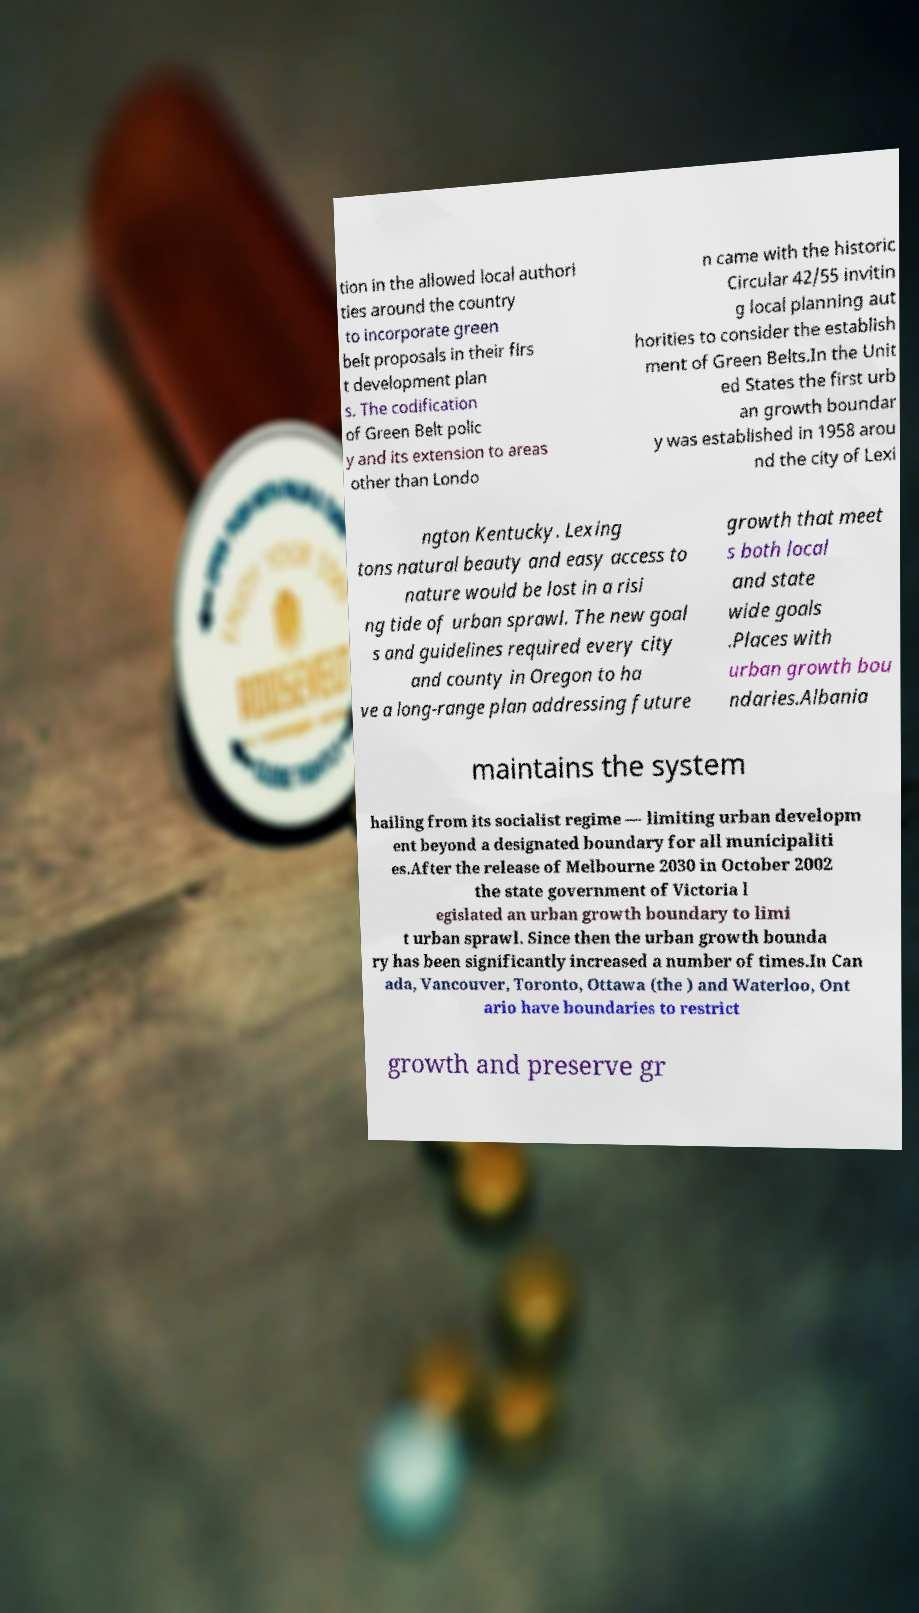For documentation purposes, I need the text within this image transcribed. Could you provide that? tion in the allowed local authori ties around the country to incorporate green belt proposals in their firs t development plan s. The codification of Green Belt polic y and its extension to areas other than Londo n came with the historic Circular 42/55 invitin g local planning aut horities to consider the establish ment of Green Belts.In the Unit ed States the first urb an growth boundar y was established in 1958 arou nd the city of Lexi ngton Kentucky. Lexing tons natural beauty and easy access to nature would be lost in a risi ng tide of urban sprawl. The new goal s and guidelines required every city and county in Oregon to ha ve a long-range plan addressing future growth that meet s both local and state wide goals .Places with urban growth bou ndaries.Albania maintains the system hailing from its socialist regime — limiting urban developm ent beyond a designated boundary for all municipaliti es.After the release of Melbourne 2030 in October 2002 the state government of Victoria l egislated an urban growth boundary to limi t urban sprawl. Since then the urban growth bounda ry has been significantly increased a number of times.In Can ada, Vancouver, Toronto, Ottawa (the ) and Waterloo, Ont ario have boundaries to restrict growth and preserve gr 